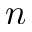<formula> <loc_0><loc_0><loc_500><loc_500>n</formula> 